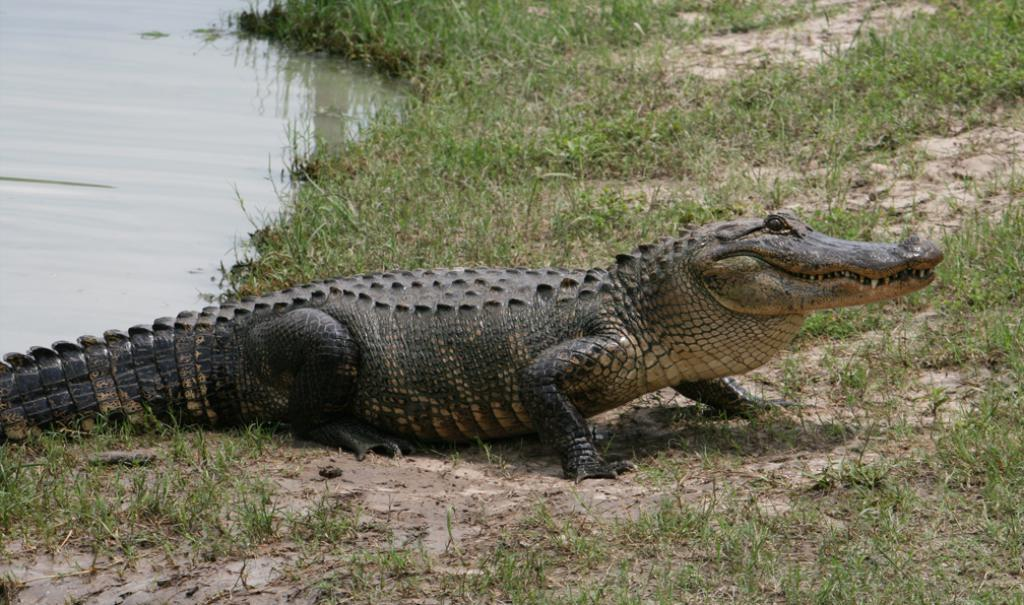What animal is in the image? There is a crocodile in the image. Where is the crocodile located? The crocodile is on the ground. What type of terrain is visible in the image? There is grass on the ground. What can be seen in the background of the image? There is water visible behind the crocodile. What type of beginner wine is recommended to pair with the crocodile's meal in the image? There is no wine or meal present in the image, so it is not possible to make a recommendation. 